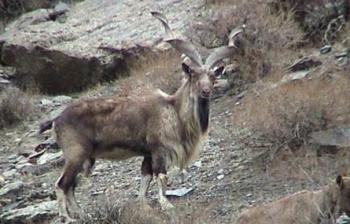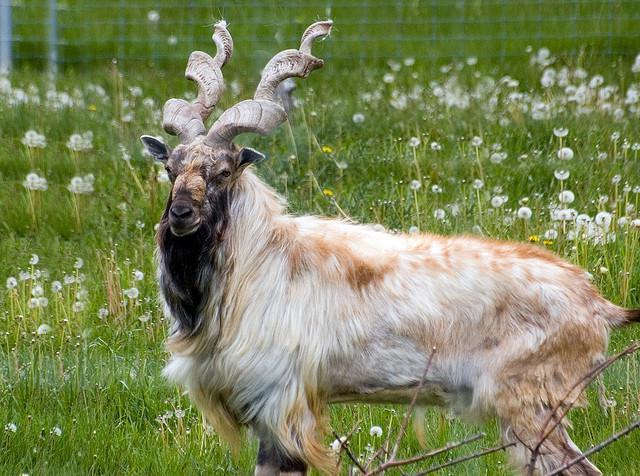The first image is the image on the left, the second image is the image on the right. Considering the images on both sides, is "The left and right image contains the same number of goats facing the same direction." valid? Answer yes or no. No. The first image is the image on the left, the second image is the image on the right. Given the left and right images, does the statement "Each image contains one horned animal in front of a wall of rock, and the animals in the left and right images face the same way and have very similar body positions." hold true? Answer yes or no. No. 